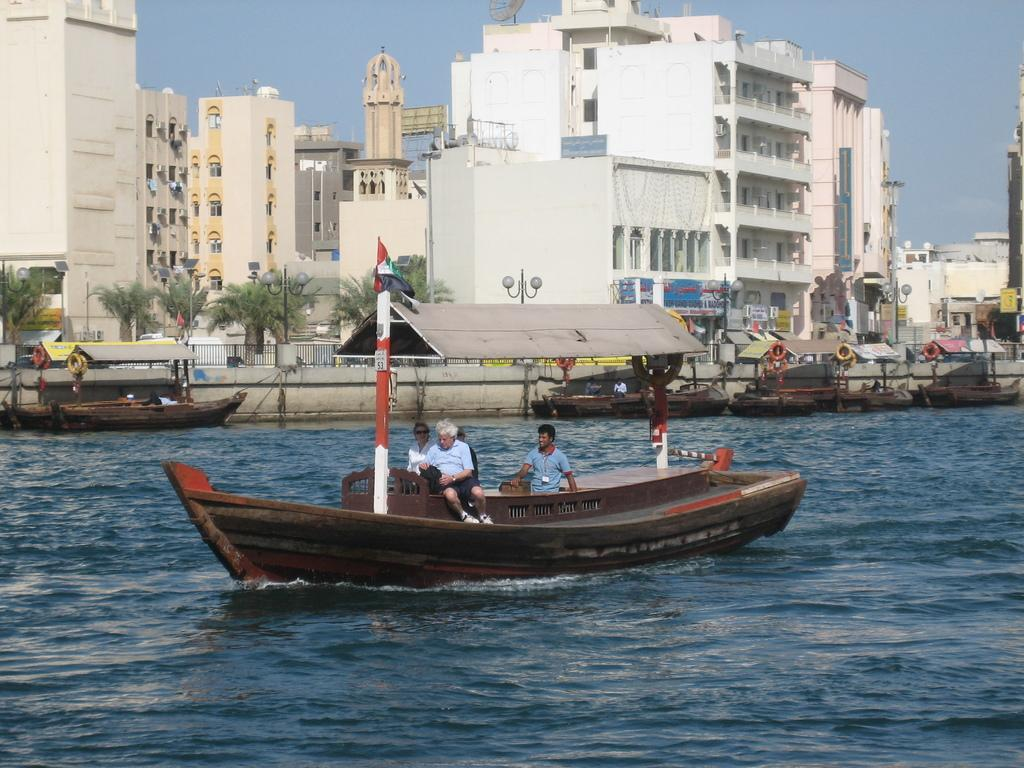What are the people in the image doing? There are persons sitting on a boat in the image. Where is the boat located? The boat is in a lake. Can you describe the surrounding environment? There are other boats visible in the image, and there are buildings behind the boats with trees in front of them. What can be seen above the scene? The sky is visible above the scene. What type of sink can be seen in the image? There is no sink present in the image; it features a boat on a lake with people sitting on it. Can you tell me how many pockets are visible on the persons sitting on the boat? There is no information about pockets on the persons sitting on the boat. 